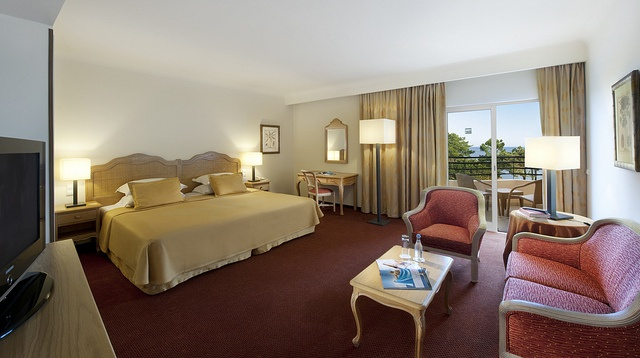Describe the objects in this image and their specific colors. I can see bed in darkgray, olive, and tan tones, couch in darkgray, maroon, brown, and gray tones, tv in darkgray, black, and gray tones, chair in darkgray, maroon, brown, gray, and black tones, and book in darkgray, lightgray, and gray tones in this image. 